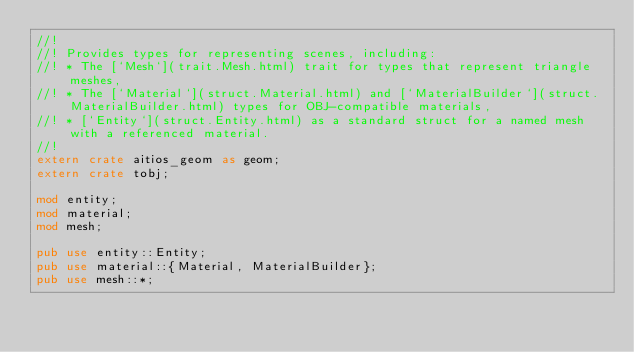Convert code to text. <code><loc_0><loc_0><loc_500><loc_500><_Rust_>//!
//! Provides types for representing scenes, including:
//! * The [`Mesh`](trait.Mesh.html) trait for types that represent triangle meshes,
//! * The [`Material`](struct.Material.html) and [`MaterialBuilder`](struct.MaterialBuilder.html) types for OBJ-compatible materials,
//! * [`Entity`](struct.Entity.html) as a standard struct for a named mesh with a referenced material.
//!
extern crate aitios_geom as geom;
extern crate tobj;

mod entity;
mod material;
mod mesh;

pub use entity::Entity;
pub use material::{Material, MaterialBuilder};
pub use mesh::*;
</code> 